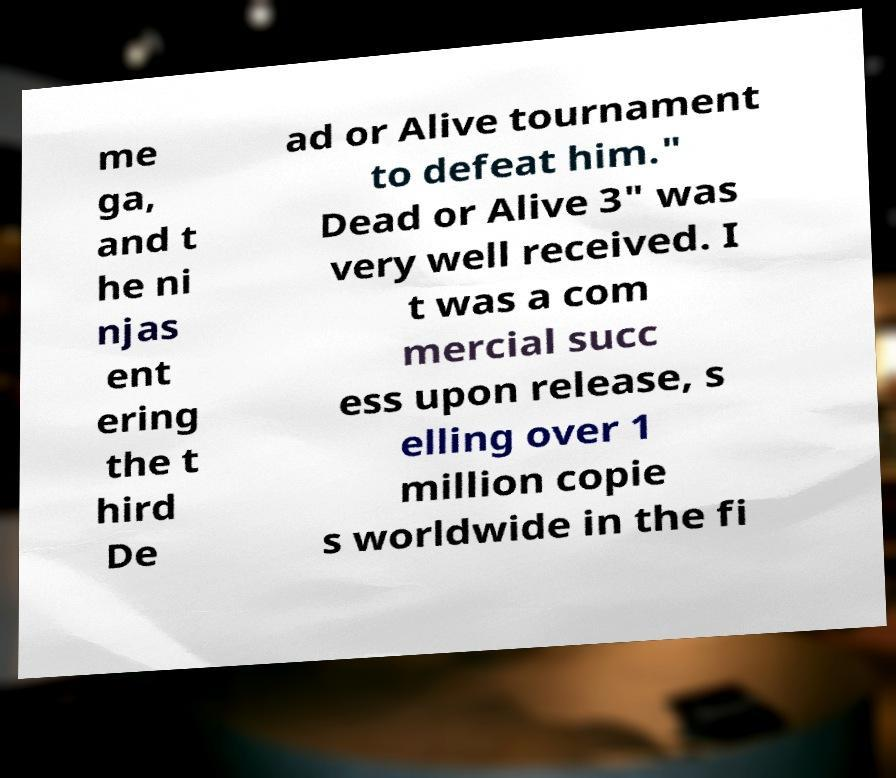For documentation purposes, I need the text within this image transcribed. Could you provide that? me ga, and t he ni njas ent ering the t hird De ad or Alive tournament to defeat him." Dead or Alive 3" was very well received. I t was a com mercial succ ess upon release, s elling over 1 million copie s worldwide in the fi 